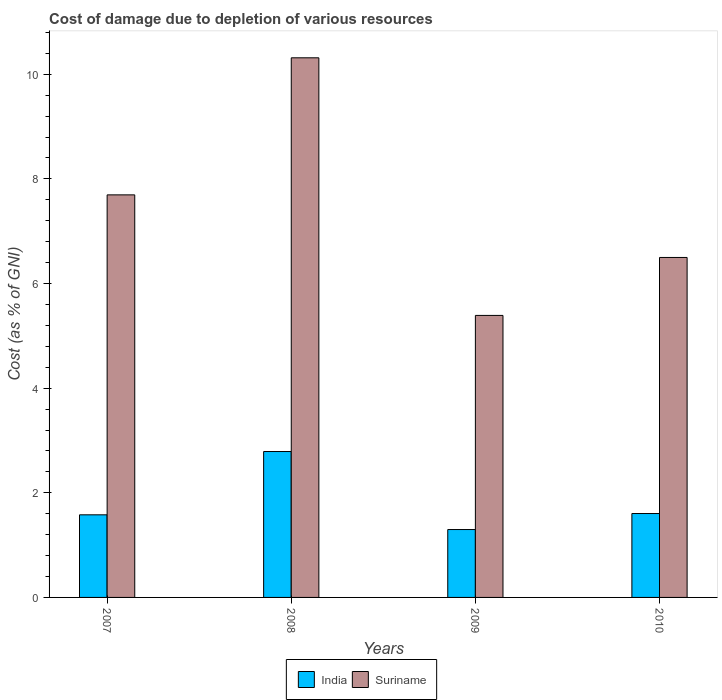Are the number of bars per tick equal to the number of legend labels?
Provide a succinct answer. Yes. How many bars are there on the 3rd tick from the left?
Make the answer very short. 2. How many bars are there on the 4th tick from the right?
Keep it short and to the point. 2. What is the label of the 3rd group of bars from the left?
Offer a very short reply. 2009. What is the cost of damage caused due to the depletion of various resources in India in 2007?
Keep it short and to the point. 1.58. Across all years, what is the maximum cost of damage caused due to the depletion of various resources in Suriname?
Offer a terse response. 10.31. Across all years, what is the minimum cost of damage caused due to the depletion of various resources in Suriname?
Give a very brief answer. 5.39. What is the total cost of damage caused due to the depletion of various resources in India in the graph?
Keep it short and to the point. 7.27. What is the difference between the cost of damage caused due to the depletion of various resources in Suriname in 2007 and that in 2009?
Your answer should be compact. 2.3. What is the difference between the cost of damage caused due to the depletion of various resources in India in 2008 and the cost of damage caused due to the depletion of various resources in Suriname in 2010?
Your response must be concise. -3.71. What is the average cost of damage caused due to the depletion of various resources in Suriname per year?
Your response must be concise. 7.47. In the year 2007, what is the difference between the cost of damage caused due to the depletion of various resources in Suriname and cost of damage caused due to the depletion of various resources in India?
Provide a short and direct response. 6.12. What is the ratio of the cost of damage caused due to the depletion of various resources in India in 2008 to that in 2009?
Ensure brevity in your answer.  2.15. Is the cost of damage caused due to the depletion of various resources in India in 2009 less than that in 2010?
Offer a very short reply. Yes. What is the difference between the highest and the second highest cost of damage caused due to the depletion of various resources in Suriname?
Make the answer very short. 2.62. What is the difference between the highest and the lowest cost of damage caused due to the depletion of various resources in Suriname?
Offer a very short reply. 4.92. Is the sum of the cost of damage caused due to the depletion of various resources in India in 2009 and 2010 greater than the maximum cost of damage caused due to the depletion of various resources in Suriname across all years?
Keep it short and to the point. No. What does the 1st bar from the right in 2010 represents?
Your response must be concise. Suriname. Are all the bars in the graph horizontal?
Your answer should be compact. No. What is the difference between two consecutive major ticks on the Y-axis?
Your response must be concise. 2. Does the graph contain any zero values?
Give a very brief answer. No. Does the graph contain grids?
Provide a succinct answer. No. Where does the legend appear in the graph?
Your answer should be very brief. Bottom center. How many legend labels are there?
Offer a very short reply. 2. How are the legend labels stacked?
Provide a succinct answer. Horizontal. What is the title of the graph?
Ensure brevity in your answer.  Cost of damage due to depletion of various resources. Does "Macedonia" appear as one of the legend labels in the graph?
Offer a very short reply. No. What is the label or title of the Y-axis?
Offer a very short reply. Cost (as % of GNI). What is the Cost (as % of GNI) of India in 2007?
Ensure brevity in your answer.  1.58. What is the Cost (as % of GNI) of Suriname in 2007?
Provide a succinct answer. 7.69. What is the Cost (as % of GNI) of India in 2008?
Make the answer very short. 2.79. What is the Cost (as % of GNI) of Suriname in 2008?
Ensure brevity in your answer.  10.31. What is the Cost (as % of GNI) of India in 2009?
Ensure brevity in your answer.  1.3. What is the Cost (as % of GNI) of Suriname in 2009?
Give a very brief answer. 5.39. What is the Cost (as % of GNI) in India in 2010?
Offer a terse response. 1.6. What is the Cost (as % of GNI) in Suriname in 2010?
Offer a very short reply. 6.5. Across all years, what is the maximum Cost (as % of GNI) in India?
Provide a short and direct response. 2.79. Across all years, what is the maximum Cost (as % of GNI) of Suriname?
Ensure brevity in your answer.  10.31. Across all years, what is the minimum Cost (as % of GNI) of India?
Your answer should be compact. 1.3. Across all years, what is the minimum Cost (as % of GNI) of Suriname?
Provide a succinct answer. 5.39. What is the total Cost (as % of GNI) in India in the graph?
Your answer should be very brief. 7.27. What is the total Cost (as % of GNI) of Suriname in the graph?
Offer a terse response. 29.9. What is the difference between the Cost (as % of GNI) of India in 2007 and that in 2008?
Provide a succinct answer. -1.21. What is the difference between the Cost (as % of GNI) in Suriname in 2007 and that in 2008?
Your answer should be very brief. -2.62. What is the difference between the Cost (as % of GNI) of India in 2007 and that in 2009?
Your response must be concise. 0.28. What is the difference between the Cost (as % of GNI) of Suriname in 2007 and that in 2009?
Keep it short and to the point. 2.3. What is the difference between the Cost (as % of GNI) of India in 2007 and that in 2010?
Provide a short and direct response. -0.02. What is the difference between the Cost (as % of GNI) in Suriname in 2007 and that in 2010?
Give a very brief answer. 1.2. What is the difference between the Cost (as % of GNI) of India in 2008 and that in 2009?
Provide a succinct answer. 1.49. What is the difference between the Cost (as % of GNI) in Suriname in 2008 and that in 2009?
Give a very brief answer. 4.92. What is the difference between the Cost (as % of GNI) of India in 2008 and that in 2010?
Your answer should be compact. 1.19. What is the difference between the Cost (as % of GNI) of Suriname in 2008 and that in 2010?
Offer a very short reply. 3.82. What is the difference between the Cost (as % of GNI) in India in 2009 and that in 2010?
Offer a terse response. -0.31. What is the difference between the Cost (as % of GNI) in Suriname in 2009 and that in 2010?
Offer a very short reply. -1.11. What is the difference between the Cost (as % of GNI) in India in 2007 and the Cost (as % of GNI) in Suriname in 2008?
Make the answer very short. -8.74. What is the difference between the Cost (as % of GNI) of India in 2007 and the Cost (as % of GNI) of Suriname in 2009?
Make the answer very short. -3.81. What is the difference between the Cost (as % of GNI) in India in 2007 and the Cost (as % of GNI) in Suriname in 2010?
Offer a very short reply. -4.92. What is the difference between the Cost (as % of GNI) in India in 2008 and the Cost (as % of GNI) in Suriname in 2009?
Provide a short and direct response. -2.6. What is the difference between the Cost (as % of GNI) in India in 2008 and the Cost (as % of GNI) in Suriname in 2010?
Give a very brief answer. -3.71. What is the difference between the Cost (as % of GNI) in India in 2009 and the Cost (as % of GNI) in Suriname in 2010?
Offer a very short reply. -5.2. What is the average Cost (as % of GNI) of India per year?
Your answer should be compact. 1.82. What is the average Cost (as % of GNI) of Suriname per year?
Your answer should be compact. 7.47. In the year 2007, what is the difference between the Cost (as % of GNI) in India and Cost (as % of GNI) in Suriname?
Make the answer very short. -6.12. In the year 2008, what is the difference between the Cost (as % of GNI) of India and Cost (as % of GNI) of Suriname?
Give a very brief answer. -7.53. In the year 2009, what is the difference between the Cost (as % of GNI) of India and Cost (as % of GNI) of Suriname?
Ensure brevity in your answer.  -4.09. In the year 2010, what is the difference between the Cost (as % of GNI) in India and Cost (as % of GNI) in Suriname?
Ensure brevity in your answer.  -4.89. What is the ratio of the Cost (as % of GNI) of India in 2007 to that in 2008?
Provide a succinct answer. 0.57. What is the ratio of the Cost (as % of GNI) of Suriname in 2007 to that in 2008?
Offer a terse response. 0.75. What is the ratio of the Cost (as % of GNI) in India in 2007 to that in 2009?
Give a very brief answer. 1.22. What is the ratio of the Cost (as % of GNI) in Suriname in 2007 to that in 2009?
Make the answer very short. 1.43. What is the ratio of the Cost (as % of GNI) in India in 2007 to that in 2010?
Provide a short and direct response. 0.98. What is the ratio of the Cost (as % of GNI) in Suriname in 2007 to that in 2010?
Give a very brief answer. 1.18. What is the ratio of the Cost (as % of GNI) of India in 2008 to that in 2009?
Offer a very short reply. 2.15. What is the ratio of the Cost (as % of GNI) of Suriname in 2008 to that in 2009?
Give a very brief answer. 1.91. What is the ratio of the Cost (as % of GNI) of India in 2008 to that in 2010?
Offer a very short reply. 1.74. What is the ratio of the Cost (as % of GNI) in Suriname in 2008 to that in 2010?
Provide a short and direct response. 1.59. What is the ratio of the Cost (as % of GNI) of India in 2009 to that in 2010?
Give a very brief answer. 0.81. What is the ratio of the Cost (as % of GNI) of Suriname in 2009 to that in 2010?
Make the answer very short. 0.83. What is the difference between the highest and the second highest Cost (as % of GNI) of India?
Keep it short and to the point. 1.19. What is the difference between the highest and the second highest Cost (as % of GNI) of Suriname?
Your response must be concise. 2.62. What is the difference between the highest and the lowest Cost (as % of GNI) in India?
Offer a terse response. 1.49. What is the difference between the highest and the lowest Cost (as % of GNI) in Suriname?
Offer a terse response. 4.92. 